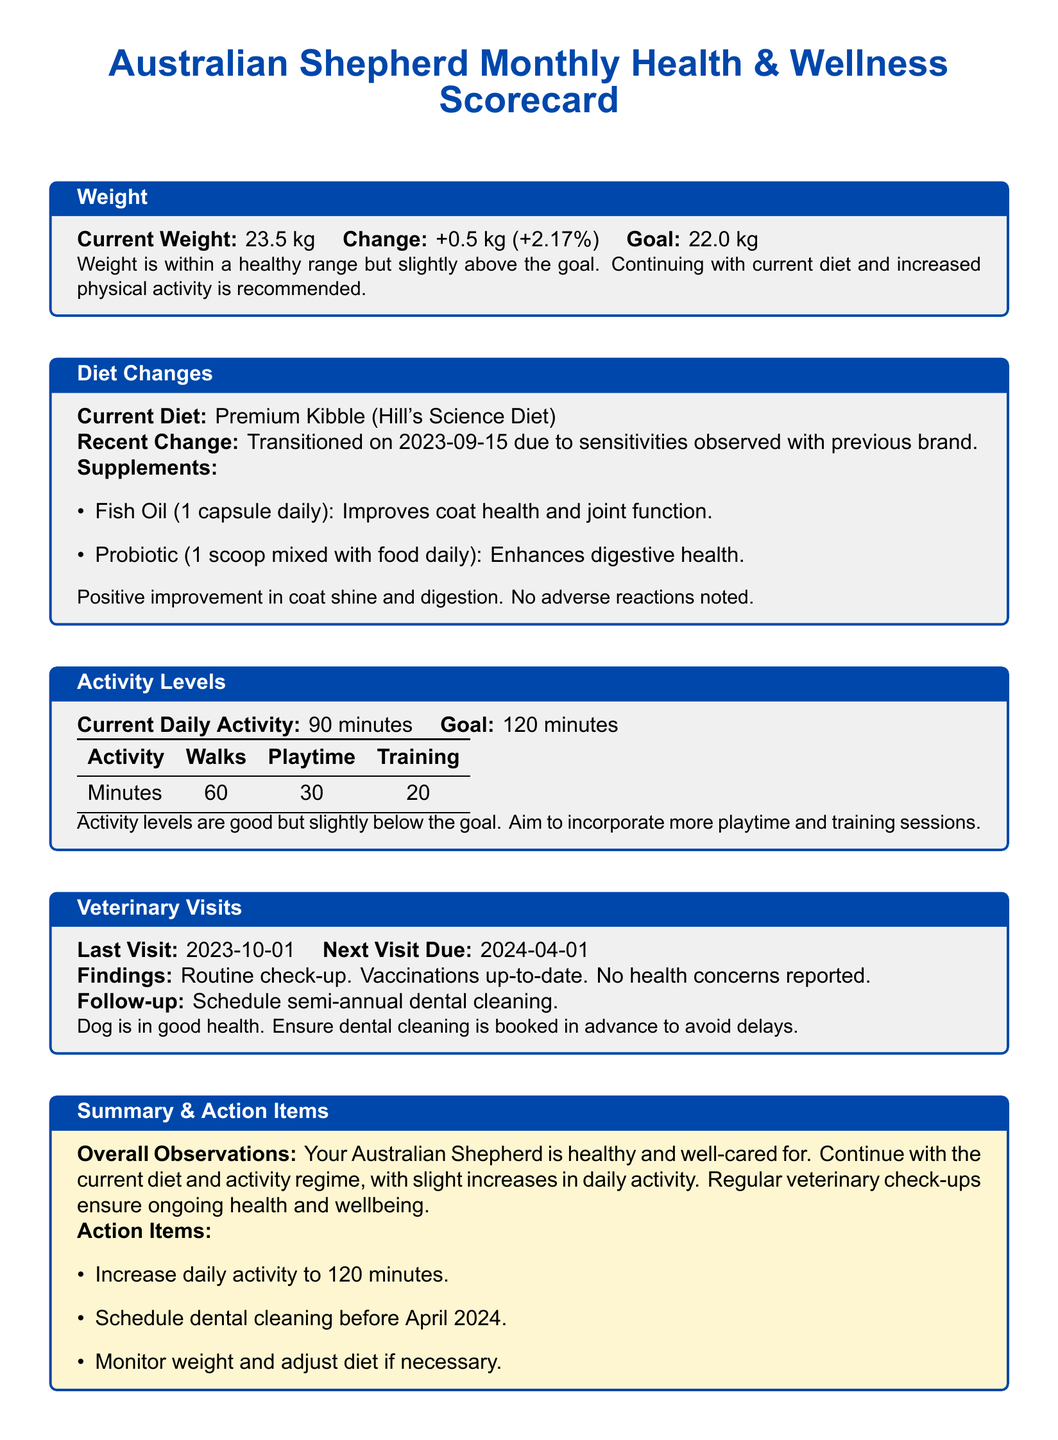What is the current weight of the dog? The current weight is provided in the Weight section of the scorecard, which states "Current Weight: 23.5 kg".
Answer: 23.5 kg What is the weight change from the previous month? The weight change is indicated in the Weight section, specified as "+0.5 kg (+2.17%)".
Answer: +0.5 kg (+2.17%) What is the goal weight for the dog? The goal weight is mentioned in the Weight section under "Goal", which is "22.0 kg".
Answer: 22.0 kg When was the last veterinary visit? The date of the last veterinary visit is presented in the Veterinary Visits section, which states "Last Visit: 2023-10-01".
Answer: 2023-10-01 How many minutes of daily activity is currently being achieved? The document specifies the current daily activity level as "90 minutes" in the Activity Levels section.
Answer: 90 minutes What is the target daily activity level for the dog? The goal for daily activity is stated in the Activity Levels section, indicated as "Goal: 120 minutes".
Answer: 120 minutes What supplement is given for coat health? The supplement for coat health mentioned in the Diet Changes section is "Fish Oil (1 capsule daily)".
Answer: Fish Oil What is the main component of the dog's current diet? The current diet is mentioned in the Diet Changes section as "Premium Kibble (Hill's Science Diet)".
Answer: Premium Kibble (Hill's Science Diet) What action item involves dental care? The action item specified for dental care refers to scheduling dental cleaning in the Summary & Action Items section.
Answer: Schedule dental cleaning 